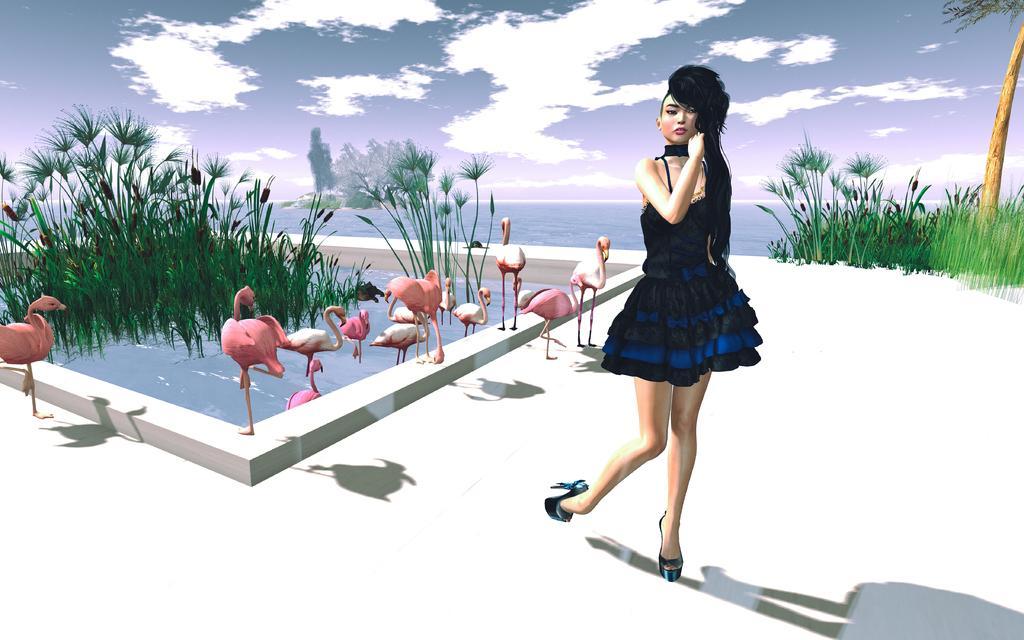Could you give a brief overview of what you see in this image? This image is a painting. There is a picture of a woman standing at right side of this image and there are some cranes in middle of this image and there are some plants as we can see at left side of this image and right side of this image as well, and there is a sea in the background and there is a sky at top of this image. 